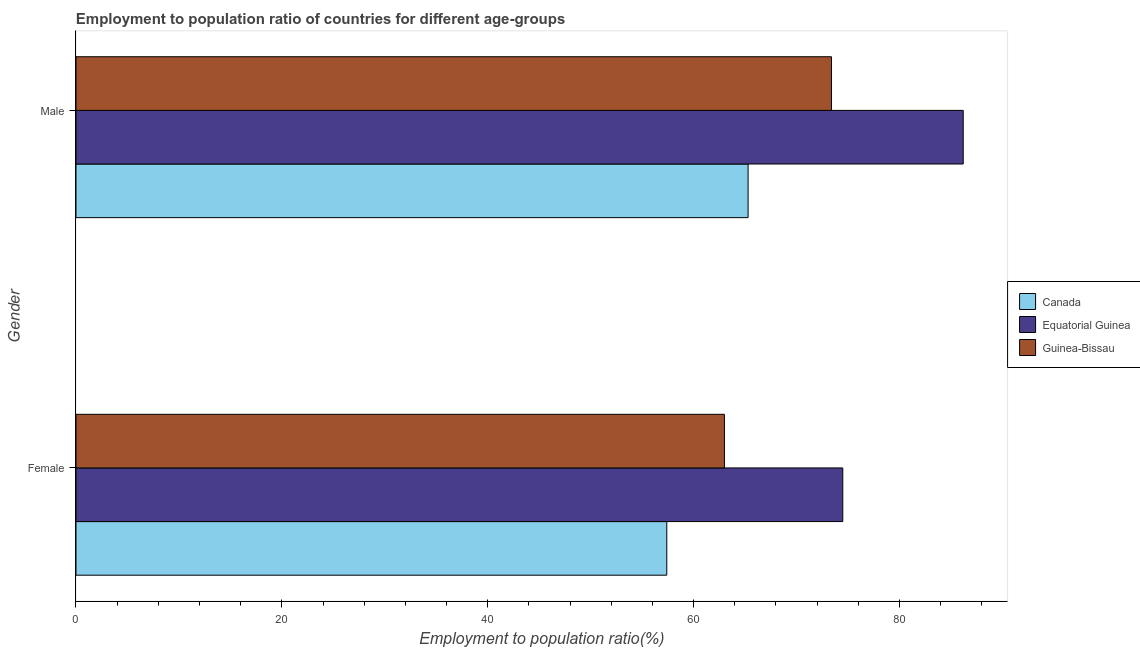Are the number of bars per tick equal to the number of legend labels?
Your answer should be very brief. Yes. What is the employment to population ratio(male) in Guinea-Bissau?
Provide a short and direct response. 73.4. Across all countries, what is the maximum employment to population ratio(male)?
Your response must be concise. 86.2. Across all countries, what is the minimum employment to population ratio(female)?
Give a very brief answer. 57.4. In which country was the employment to population ratio(male) maximum?
Make the answer very short. Equatorial Guinea. In which country was the employment to population ratio(male) minimum?
Keep it short and to the point. Canada. What is the total employment to population ratio(male) in the graph?
Give a very brief answer. 224.9. What is the difference between the employment to population ratio(male) in Canada and that in Equatorial Guinea?
Your response must be concise. -20.9. What is the difference between the employment to population ratio(female) in Canada and the employment to population ratio(male) in Guinea-Bissau?
Offer a very short reply. -16. What is the average employment to population ratio(female) per country?
Ensure brevity in your answer.  64.97. What is the difference between the employment to population ratio(female) and employment to population ratio(male) in Guinea-Bissau?
Offer a terse response. -10.4. What is the ratio of the employment to population ratio(male) in Guinea-Bissau to that in Equatorial Guinea?
Provide a short and direct response. 0.85. What does the 2nd bar from the top in Male represents?
Give a very brief answer. Equatorial Guinea. What does the 3rd bar from the bottom in Female represents?
Your answer should be very brief. Guinea-Bissau. How many bars are there?
Make the answer very short. 6. How many countries are there in the graph?
Your answer should be very brief. 3. What is the difference between two consecutive major ticks on the X-axis?
Your answer should be very brief. 20. Are the values on the major ticks of X-axis written in scientific E-notation?
Give a very brief answer. No. Where does the legend appear in the graph?
Make the answer very short. Center right. How are the legend labels stacked?
Your answer should be compact. Vertical. What is the title of the graph?
Give a very brief answer. Employment to population ratio of countries for different age-groups. Does "Fiji" appear as one of the legend labels in the graph?
Your answer should be very brief. No. What is the label or title of the Y-axis?
Provide a succinct answer. Gender. What is the Employment to population ratio(%) of Canada in Female?
Keep it short and to the point. 57.4. What is the Employment to population ratio(%) of Equatorial Guinea in Female?
Make the answer very short. 74.5. What is the Employment to population ratio(%) in Guinea-Bissau in Female?
Your response must be concise. 63. What is the Employment to population ratio(%) of Canada in Male?
Keep it short and to the point. 65.3. What is the Employment to population ratio(%) in Equatorial Guinea in Male?
Offer a very short reply. 86.2. What is the Employment to population ratio(%) of Guinea-Bissau in Male?
Make the answer very short. 73.4. Across all Gender, what is the maximum Employment to population ratio(%) in Canada?
Keep it short and to the point. 65.3. Across all Gender, what is the maximum Employment to population ratio(%) in Equatorial Guinea?
Provide a short and direct response. 86.2. Across all Gender, what is the maximum Employment to population ratio(%) of Guinea-Bissau?
Offer a terse response. 73.4. Across all Gender, what is the minimum Employment to population ratio(%) in Canada?
Keep it short and to the point. 57.4. Across all Gender, what is the minimum Employment to population ratio(%) in Equatorial Guinea?
Offer a terse response. 74.5. Across all Gender, what is the minimum Employment to population ratio(%) in Guinea-Bissau?
Give a very brief answer. 63. What is the total Employment to population ratio(%) of Canada in the graph?
Provide a succinct answer. 122.7. What is the total Employment to population ratio(%) in Equatorial Guinea in the graph?
Ensure brevity in your answer.  160.7. What is the total Employment to population ratio(%) of Guinea-Bissau in the graph?
Offer a very short reply. 136.4. What is the difference between the Employment to population ratio(%) in Canada in Female and that in Male?
Make the answer very short. -7.9. What is the difference between the Employment to population ratio(%) of Equatorial Guinea in Female and that in Male?
Provide a succinct answer. -11.7. What is the difference between the Employment to population ratio(%) in Canada in Female and the Employment to population ratio(%) in Equatorial Guinea in Male?
Your answer should be very brief. -28.8. What is the difference between the Employment to population ratio(%) of Equatorial Guinea in Female and the Employment to population ratio(%) of Guinea-Bissau in Male?
Provide a succinct answer. 1.1. What is the average Employment to population ratio(%) of Canada per Gender?
Your answer should be compact. 61.35. What is the average Employment to population ratio(%) of Equatorial Guinea per Gender?
Offer a very short reply. 80.35. What is the average Employment to population ratio(%) in Guinea-Bissau per Gender?
Provide a short and direct response. 68.2. What is the difference between the Employment to population ratio(%) of Canada and Employment to population ratio(%) of Equatorial Guinea in Female?
Offer a terse response. -17.1. What is the difference between the Employment to population ratio(%) of Canada and Employment to population ratio(%) of Guinea-Bissau in Female?
Offer a terse response. -5.6. What is the difference between the Employment to population ratio(%) of Equatorial Guinea and Employment to population ratio(%) of Guinea-Bissau in Female?
Provide a short and direct response. 11.5. What is the difference between the Employment to population ratio(%) of Canada and Employment to population ratio(%) of Equatorial Guinea in Male?
Make the answer very short. -20.9. What is the difference between the Employment to population ratio(%) of Equatorial Guinea and Employment to population ratio(%) of Guinea-Bissau in Male?
Provide a succinct answer. 12.8. What is the ratio of the Employment to population ratio(%) of Canada in Female to that in Male?
Provide a short and direct response. 0.88. What is the ratio of the Employment to population ratio(%) in Equatorial Guinea in Female to that in Male?
Offer a very short reply. 0.86. What is the ratio of the Employment to population ratio(%) in Guinea-Bissau in Female to that in Male?
Your answer should be compact. 0.86. What is the difference between the highest and the second highest Employment to population ratio(%) of Canada?
Ensure brevity in your answer.  7.9. What is the difference between the highest and the lowest Employment to population ratio(%) in Canada?
Keep it short and to the point. 7.9. What is the difference between the highest and the lowest Employment to population ratio(%) in Guinea-Bissau?
Give a very brief answer. 10.4. 